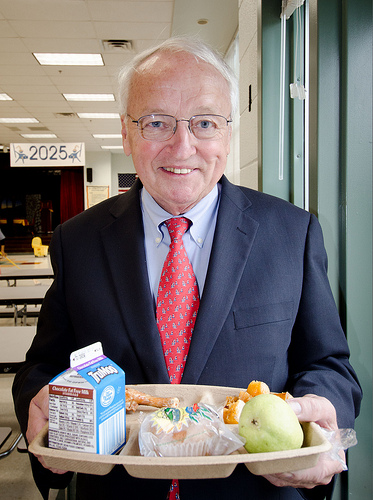<image>
Is the milk to the left of the chicken? Yes. From this viewpoint, the milk is positioned to the left side relative to the chicken. Where is the mop bucket in relation to the man? Is it to the left of the man? No. The mop bucket is not to the left of the man. From this viewpoint, they have a different horizontal relationship. 